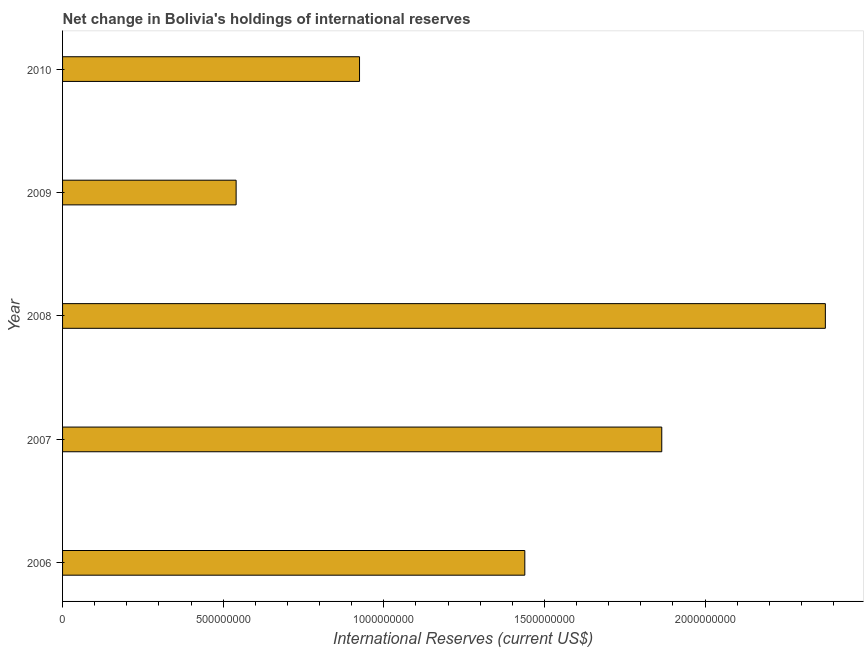Does the graph contain grids?
Offer a very short reply. No. What is the title of the graph?
Your response must be concise. Net change in Bolivia's holdings of international reserves. What is the label or title of the X-axis?
Offer a terse response. International Reserves (current US$). What is the label or title of the Y-axis?
Make the answer very short. Year. What is the reserves and related items in 2010?
Your response must be concise. 9.24e+08. Across all years, what is the maximum reserves and related items?
Offer a very short reply. 2.37e+09. Across all years, what is the minimum reserves and related items?
Offer a terse response. 5.40e+08. In which year was the reserves and related items maximum?
Keep it short and to the point. 2008. In which year was the reserves and related items minimum?
Your answer should be compact. 2009. What is the sum of the reserves and related items?
Your answer should be compact. 7.14e+09. What is the difference between the reserves and related items in 2007 and 2010?
Offer a terse response. 9.41e+08. What is the average reserves and related items per year?
Your answer should be compact. 1.43e+09. What is the median reserves and related items?
Offer a terse response. 1.44e+09. Do a majority of the years between 2008 and 2007 (inclusive) have reserves and related items greater than 1400000000 US$?
Keep it short and to the point. No. What is the ratio of the reserves and related items in 2007 to that in 2008?
Ensure brevity in your answer.  0.79. What is the difference between the highest and the second highest reserves and related items?
Keep it short and to the point. 5.09e+08. Is the sum of the reserves and related items in 2006 and 2009 greater than the maximum reserves and related items across all years?
Provide a short and direct response. No. What is the difference between the highest and the lowest reserves and related items?
Give a very brief answer. 1.83e+09. In how many years, is the reserves and related items greater than the average reserves and related items taken over all years?
Your answer should be compact. 3. How many bars are there?
Your response must be concise. 5. How many years are there in the graph?
Your response must be concise. 5. What is the difference between two consecutive major ticks on the X-axis?
Provide a short and direct response. 5.00e+08. Are the values on the major ticks of X-axis written in scientific E-notation?
Ensure brevity in your answer.  No. What is the International Reserves (current US$) of 2006?
Provide a short and direct response. 1.44e+09. What is the International Reserves (current US$) of 2007?
Keep it short and to the point. 1.87e+09. What is the International Reserves (current US$) of 2008?
Make the answer very short. 2.37e+09. What is the International Reserves (current US$) in 2009?
Ensure brevity in your answer.  5.40e+08. What is the International Reserves (current US$) in 2010?
Provide a succinct answer. 9.24e+08. What is the difference between the International Reserves (current US$) in 2006 and 2007?
Give a very brief answer. -4.26e+08. What is the difference between the International Reserves (current US$) in 2006 and 2008?
Your response must be concise. -9.35e+08. What is the difference between the International Reserves (current US$) in 2006 and 2009?
Offer a very short reply. 8.99e+08. What is the difference between the International Reserves (current US$) in 2006 and 2010?
Ensure brevity in your answer.  5.14e+08. What is the difference between the International Reserves (current US$) in 2007 and 2008?
Your answer should be compact. -5.09e+08. What is the difference between the International Reserves (current US$) in 2007 and 2009?
Make the answer very short. 1.32e+09. What is the difference between the International Reserves (current US$) in 2007 and 2010?
Make the answer very short. 9.41e+08. What is the difference between the International Reserves (current US$) in 2008 and 2009?
Keep it short and to the point. 1.83e+09. What is the difference between the International Reserves (current US$) in 2008 and 2010?
Your response must be concise. 1.45e+09. What is the difference between the International Reserves (current US$) in 2009 and 2010?
Ensure brevity in your answer.  -3.84e+08. What is the ratio of the International Reserves (current US$) in 2006 to that in 2007?
Ensure brevity in your answer.  0.77. What is the ratio of the International Reserves (current US$) in 2006 to that in 2008?
Make the answer very short. 0.61. What is the ratio of the International Reserves (current US$) in 2006 to that in 2009?
Your response must be concise. 2.66. What is the ratio of the International Reserves (current US$) in 2006 to that in 2010?
Make the answer very short. 1.56. What is the ratio of the International Reserves (current US$) in 2007 to that in 2008?
Provide a succinct answer. 0.79. What is the ratio of the International Reserves (current US$) in 2007 to that in 2009?
Your response must be concise. 3.45. What is the ratio of the International Reserves (current US$) in 2007 to that in 2010?
Your response must be concise. 2.02. What is the ratio of the International Reserves (current US$) in 2008 to that in 2009?
Your answer should be very brief. 4.39. What is the ratio of the International Reserves (current US$) in 2008 to that in 2010?
Keep it short and to the point. 2.57. What is the ratio of the International Reserves (current US$) in 2009 to that in 2010?
Ensure brevity in your answer.  0.58. 